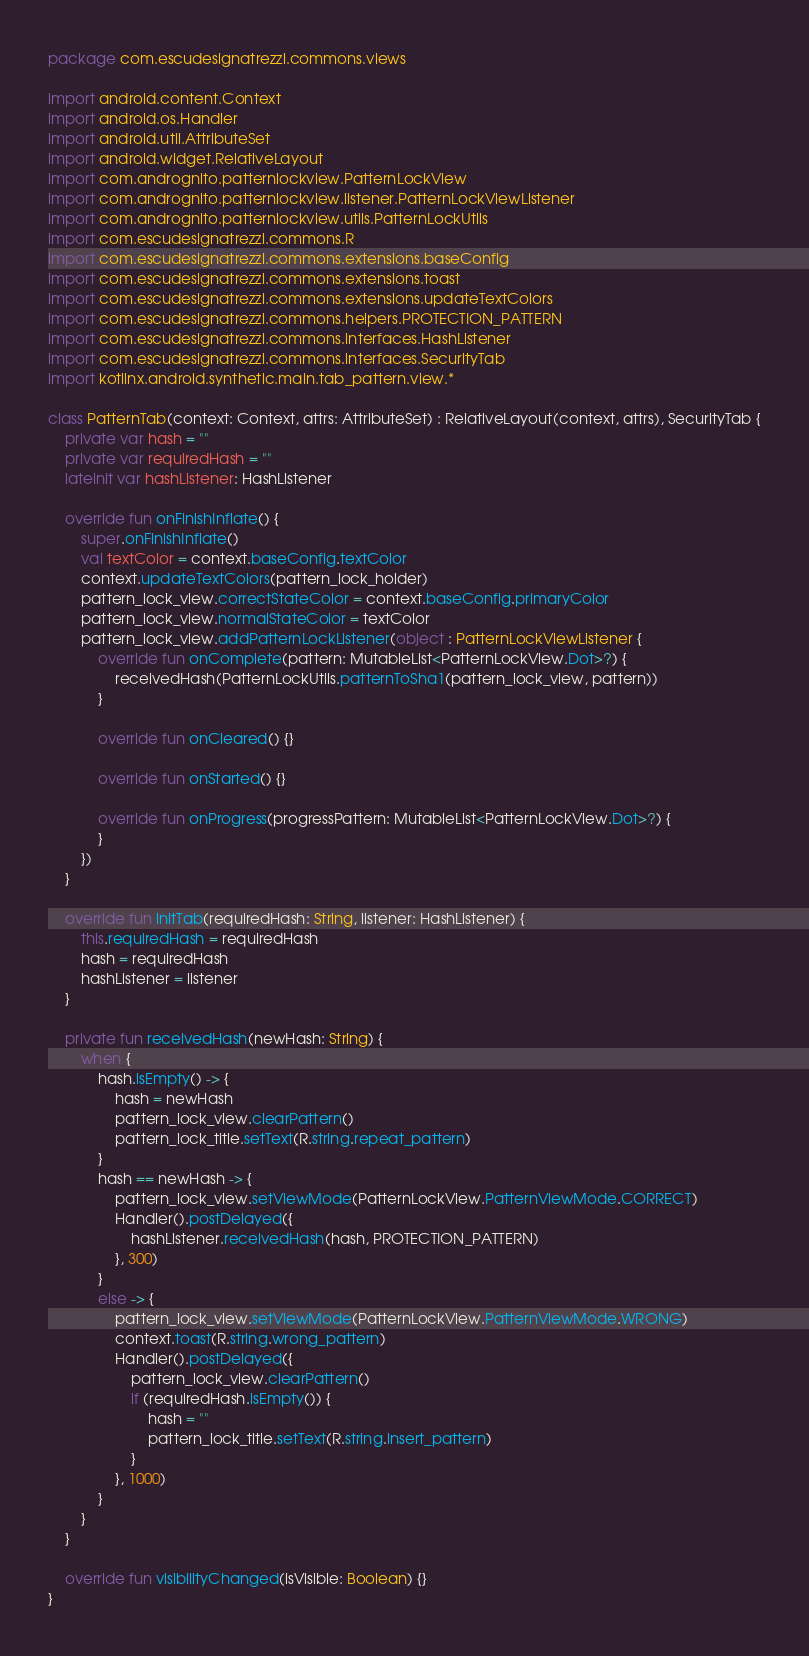<code> <loc_0><loc_0><loc_500><loc_500><_Kotlin_>package com.escudesignatrezzi.commons.views

import android.content.Context
import android.os.Handler
import android.util.AttributeSet
import android.widget.RelativeLayout
import com.andrognito.patternlockview.PatternLockView
import com.andrognito.patternlockview.listener.PatternLockViewListener
import com.andrognito.patternlockview.utils.PatternLockUtils
import com.escudesignatrezzi.commons.R
import com.escudesignatrezzi.commons.extensions.baseConfig
import com.escudesignatrezzi.commons.extensions.toast
import com.escudesignatrezzi.commons.extensions.updateTextColors
import com.escudesignatrezzi.commons.helpers.PROTECTION_PATTERN
import com.escudesignatrezzi.commons.interfaces.HashListener
import com.escudesignatrezzi.commons.interfaces.SecurityTab
import kotlinx.android.synthetic.main.tab_pattern.view.*

class PatternTab(context: Context, attrs: AttributeSet) : RelativeLayout(context, attrs), SecurityTab {
    private var hash = ""
    private var requiredHash = ""
    lateinit var hashListener: HashListener

    override fun onFinishInflate() {
        super.onFinishInflate()
        val textColor = context.baseConfig.textColor
        context.updateTextColors(pattern_lock_holder)
        pattern_lock_view.correctStateColor = context.baseConfig.primaryColor
        pattern_lock_view.normalStateColor = textColor
        pattern_lock_view.addPatternLockListener(object : PatternLockViewListener {
            override fun onComplete(pattern: MutableList<PatternLockView.Dot>?) {
                receivedHash(PatternLockUtils.patternToSha1(pattern_lock_view, pattern))
            }

            override fun onCleared() {}

            override fun onStarted() {}

            override fun onProgress(progressPattern: MutableList<PatternLockView.Dot>?) {
            }
        })
    }

    override fun initTab(requiredHash: String, listener: HashListener) {
        this.requiredHash = requiredHash
        hash = requiredHash
        hashListener = listener
    }

    private fun receivedHash(newHash: String) {
        when {
            hash.isEmpty() -> {
                hash = newHash
                pattern_lock_view.clearPattern()
                pattern_lock_title.setText(R.string.repeat_pattern)
            }
            hash == newHash -> {
                pattern_lock_view.setViewMode(PatternLockView.PatternViewMode.CORRECT)
                Handler().postDelayed({
                    hashListener.receivedHash(hash, PROTECTION_PATTERN)
                }, 300)
            }
            else -> {
                pattern_lock_view.setViewMode(PatternLockView.PatternViewMode.WRONG)
                context.toast(R.string.wrong_pattern)
                Handler().postDelayed({
                    pattern_lock_view.clearPattern()
                    if (requiredHash.isEmpty()) {
                        hash = ""
                        pattern_lock_title.setText(R.string.insert_pattern)
                    }
                }, 1000)
            }
        }
    }

    override fun visibilityChanged(isVisible: Boolean) {}
}
</code> 